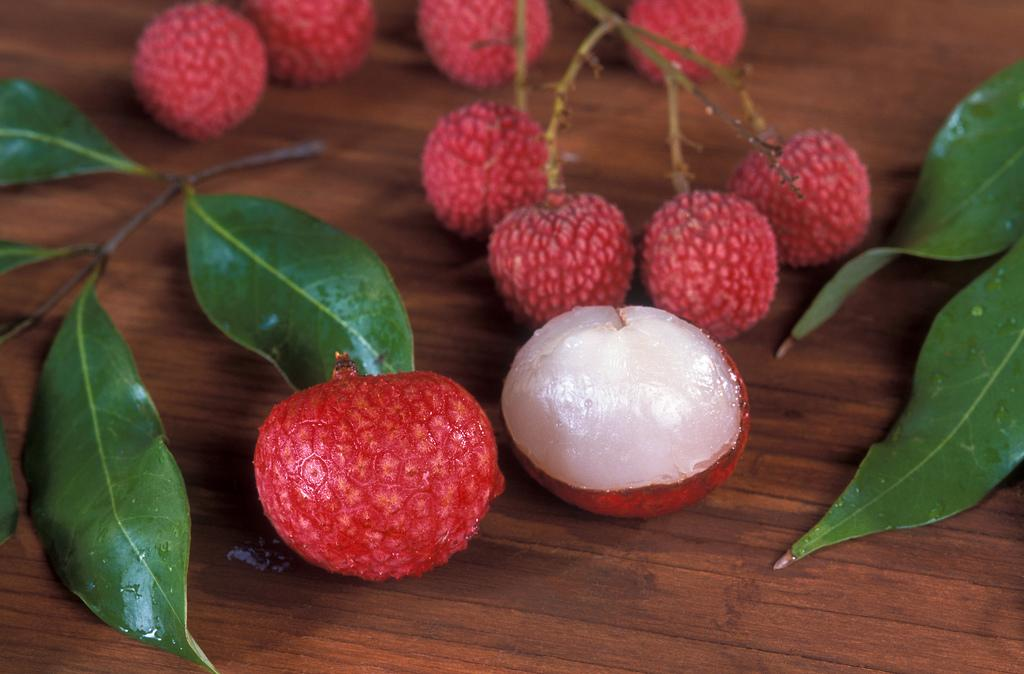What type of fruit is present on the table in the image? There are litchis on the table. What else can be seen beside the litchis on the table? There are leaves beside the litchis. What type of pancake is being served with the litchis in the image? There is no pancake present in the image; it only features litchis and leaves. 